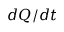<formula> <loc_0><loc_0><loc_500><loc_500>d Q / d t</formula> 